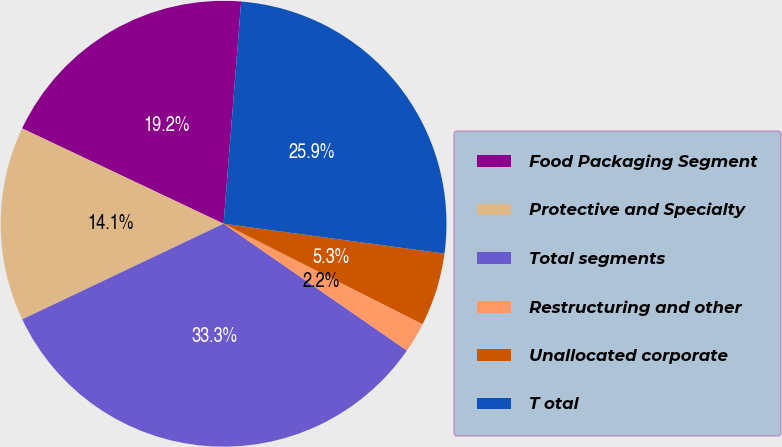Convert chart. <chart><loc_0><loc_0><loc_500><loc_500><pie_chart><fcel>Food Packaging Segment<fcel>Protective and Specialty<fcel>Total segments<fcel>Restructuring and other<fcel>Unallocated corporate<fcel>T otal<nl><fcel>19.22%<fcel>14.09%<fcel>33.31%<fcel>2.19%<fcel>5.3%<fcel>25.88%<nl></chart> 